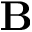<formula> <loc_0><loc_0><loc_500><loc_500>B</formula> 